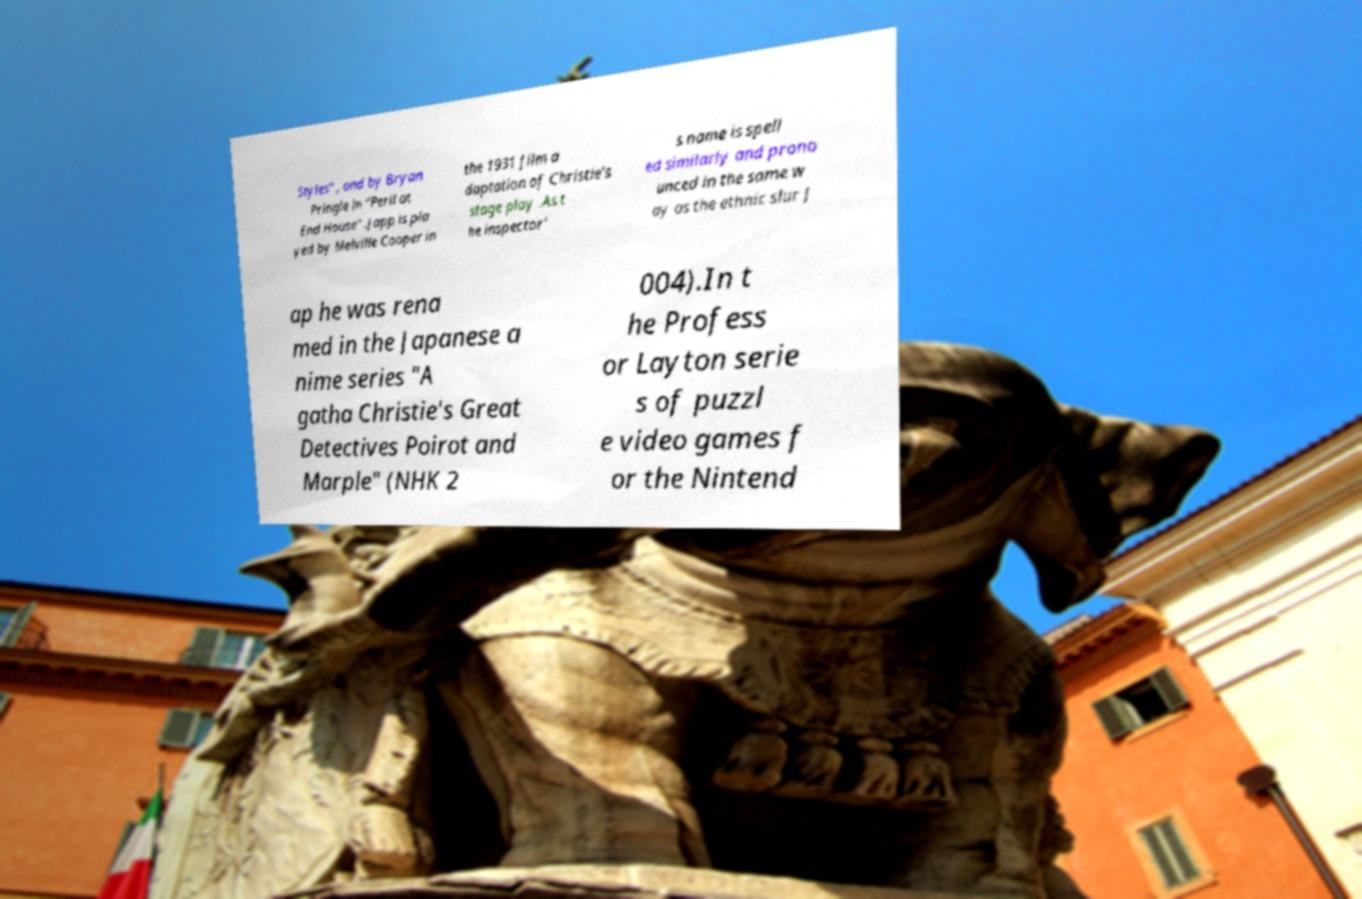Please identify and transcribe the text found in this image. Styles" , and by Bryan Pringle in "Peril at End House" .Japp is pla yed by Melville Cooper in the 1931 film a daptation of Christie's stage play .As t he inspector' s name is spell ed similarly and prono unced in the same w ay as the ethnic slur J ap he was rena med in the Japanese a nime series "A gatha Christie's Great Detectives Poirot and Marple" (NHK 2 004).In t he Profess or Layton serie s of puzzl e video games f or the Nintend 